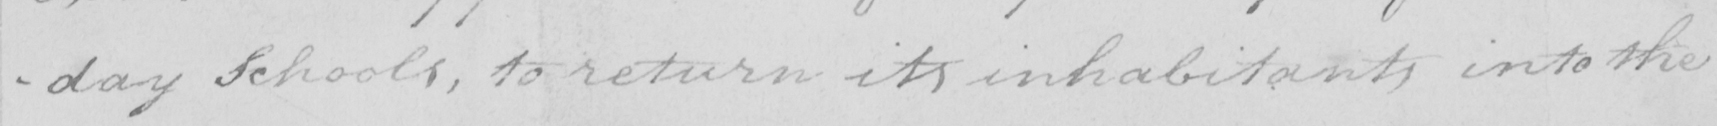What does this handwritten line say? -day Schools , to return its inhabitants into the 